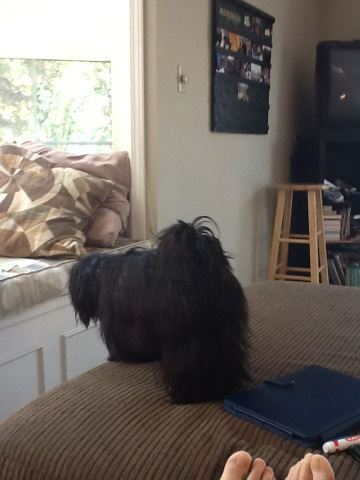What breed of dog is this? This appears to be a small breed dog, possibly a Shih Tzu or a Lhasa Apso, given its long and fluffy black coat. Such breeds are known for their long, flowing hair and friendly demeanor. Does this breed require a lot of grooming? Yes, breeds like Shih Tzus or Lhasa Apsos require regular grooming, including brushing and occasional hair trims, to keep their long coats free from tangles and mats. Regular grooming also helps keep the dog's skin healthy and comfortable. 